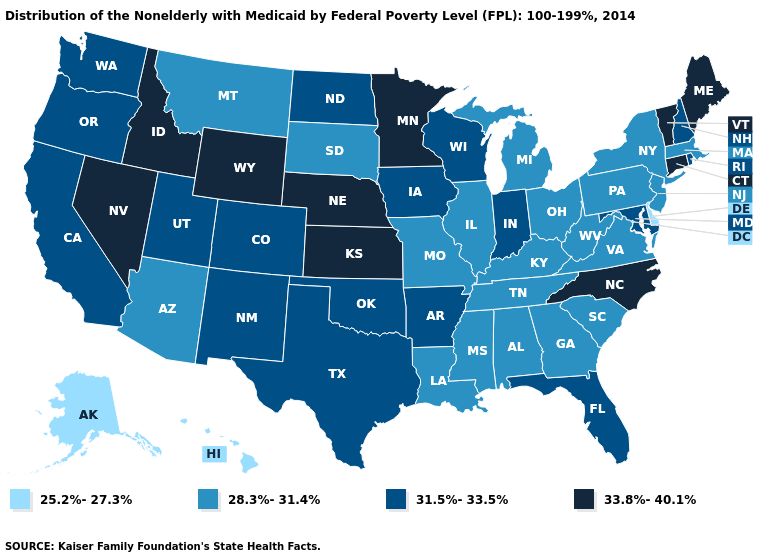Name the states that have a value in the range 33.8%-40.1%?
Short answer required. Connecticut, Idaho, Kansas, Maine, Minnesota, Nebraska, Nevada, North Carolina, Vermont, Wyoming. What is the value of Oregon?
Quick response, please. 31.5%-33.5%. What is the value of Pennsylvania?
Concise answer only. 28.3%-31.4%. Name the states that have a value in the range 28.3%-31.4%?
Keep it brief. Alabama, Arizona, Georgia, Illinois, Kentucky, Louisiana, Massachusetts, Michigan, Mississippi, Missouri, Montana, New Jersey, New York, Ohio, Pennsylvania, South Carolina, South Dakota, Tennessee, Virginia, West Virginia. Name the states that have a value in the range 28.3%-31.4%?
Be succinct. Alabama, Arizona, Georgia, Illinois, Kentucky, Louisiana, Massachusetts, Michigan, Mississippi, Missouri, Montana, New Jersey, New York, Ohio, Pennsylvania, South Carolina, South Dakota, Tennessee, Virginia, West Virginia. What is the highest value in the USA?
Concise answer only. 33.8%-40.1%. What is the lowest value in states that border Indiana?
Answer briefly. 28.3%-31.4%. Among the states that border Tennessee , does North Carolina have the highest value?
Be succinct. Yes. Which states have the lowest value in the USA?
Concise answer only. Alaska, Delaware, Hawaii. Name the states that have a value in the range 28.3%-31.4%?
Concise answer only. Alabama, Arizona, Georgia, Illinois, Kentucky, Louisiana, Massachusetts, Michigan, Mississippi, Missouri, Montana, New Jersey, New York, Ohio, Pennsylvania, South Carolina, South Dakota, Tennessee, Virginia, West Virginia. Does Hawaii have the lowest value in the West?
Be succinct. Yes. Which states hav the highest value in the West?
Be succinct. Idaho, Nevada, Wyoming. What is the value of Utah?
Short answer required. 31.5%-33.5%. Does Oklahoma have the lowest value in the USA?
Be succinct. No. Name the states that have a value in the range 33.8%-40.1%?
Concise answer only. Connecticut, Idaho, Kansas, Maine, Minnesota, Nebraska, Nevada, North Carolina, Vermont, Wyoming. 